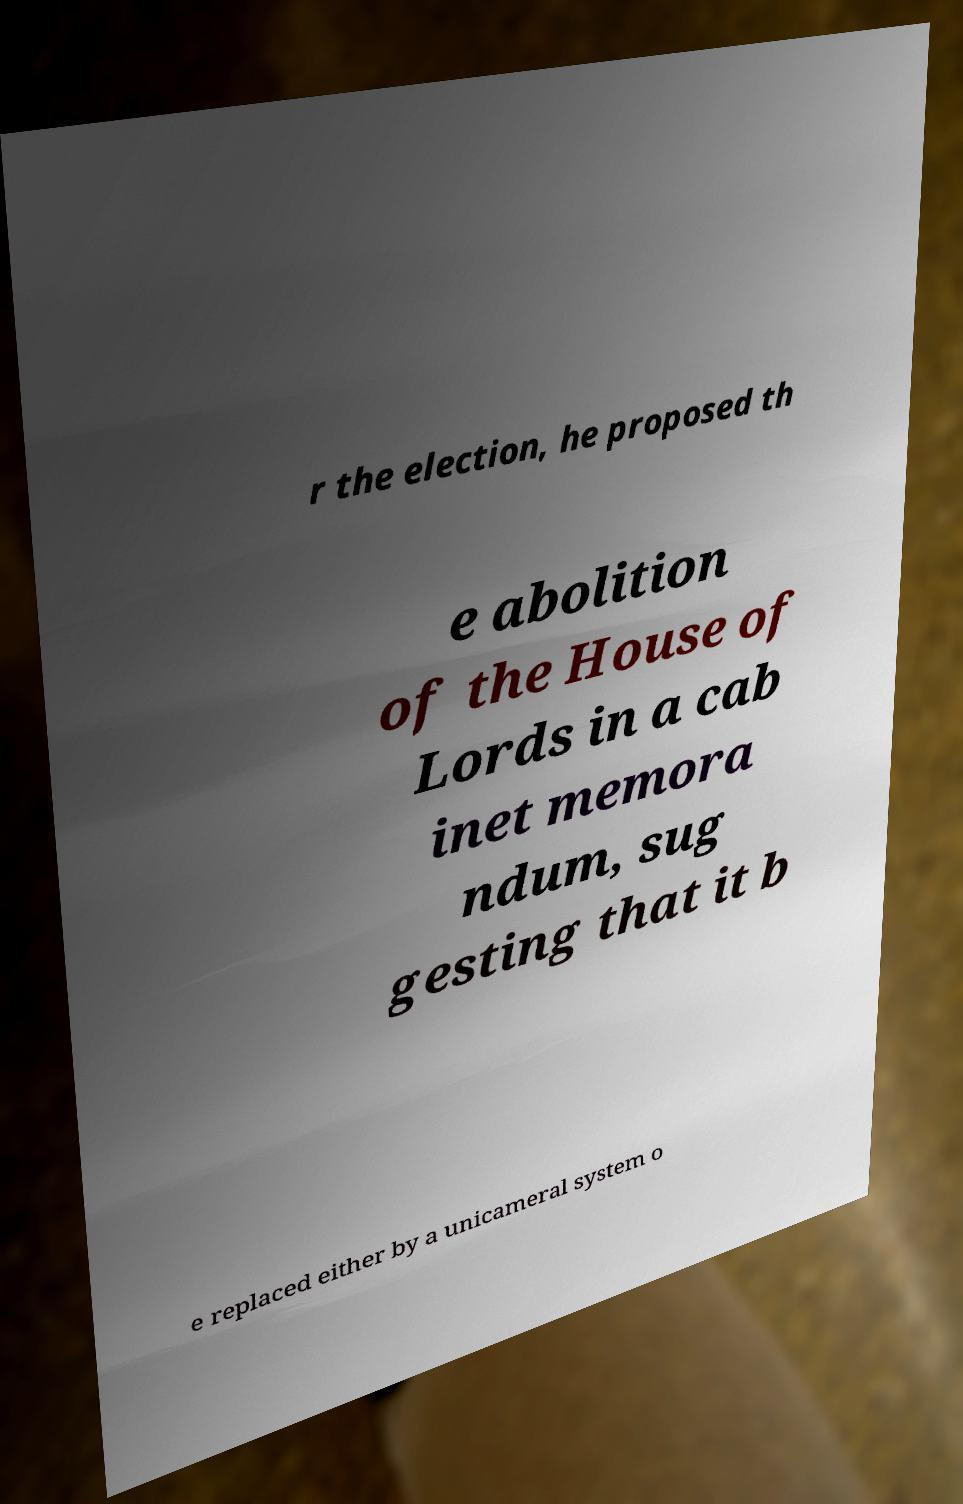Could you assist in decoding the text presented in this image and type it out clearly? r the election, he proposed th e abolition of the House of Lords in a cab inet memora ndum, sug gesting that it b e replaced either by a unicameral system o 